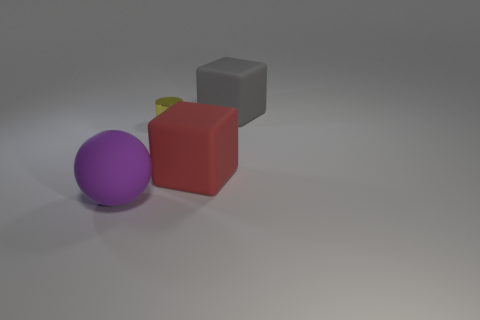Are there any matte things that are in front of the block that is in front of the cube that is behind the tiny shiny cylinder?
Give a very brief answer. Yes. What is the size of the red matte block?
Keep it short and to the point. Large. How many objects are either yellow rubber spheres or tiny cylinders?
Provide a succinct answer. 1. What color is the block that is made of the same material as the large gray object?
Make the answer very short. Red. Is the shape of the large object that is left of the yellow thing the same as  the gray thing?
Ensure brevity in your answer.  No. What number of things are big rubber objects that are left of the big red cube or cubes that are behind the yellow metallic cylinder?
Give a very brief answer. 2. There is another thing that is the same shape as the red object; what color is it?
Provide a short and direct response. Gray. Are there any other things that have the same shape as the tiny object?
Ensure brevity in your answer.  No. Does the big gray thing have the same shape as the rubber object to the left of the small yellow object?
Your response must be concise. No. What is the material of the purple thing?
Your response must be concise. Rubber. 